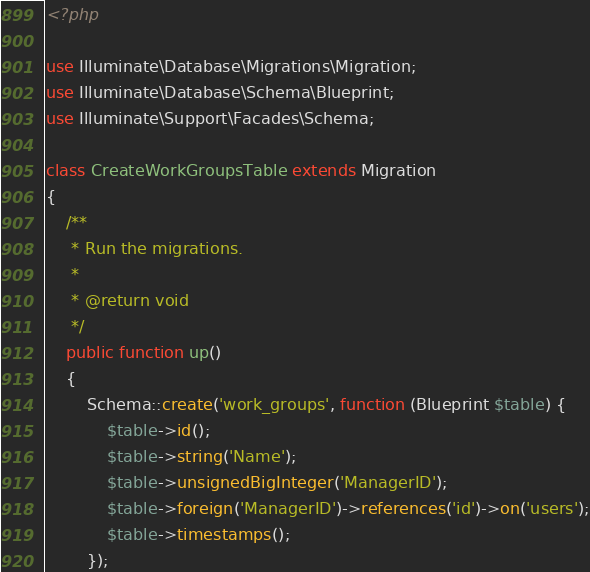<code> <loc_0><loc_0><loc_500><loc_500><_PHP_><?php

use Illuminate\Database\Migrations\Migration;
use Illuminate\Database\Schema\Blueprint;
use Illuminate\Support\Facades\Schema;

class CreateWorkGroupsTable extends Migration
{
    /**
     * Run the migrations.
     *
     * @return void
     */
    public function up()
    {
        Schema::create('work_groups', function (Blueprint $table) {
            $table->id();
            $table->string('Name');
            $table->unsignedBigInteger('ManagerID');
            $table->foreign('ManagerID')->references('id')->on('users');
            $table->timestamps();
        });
</code> 